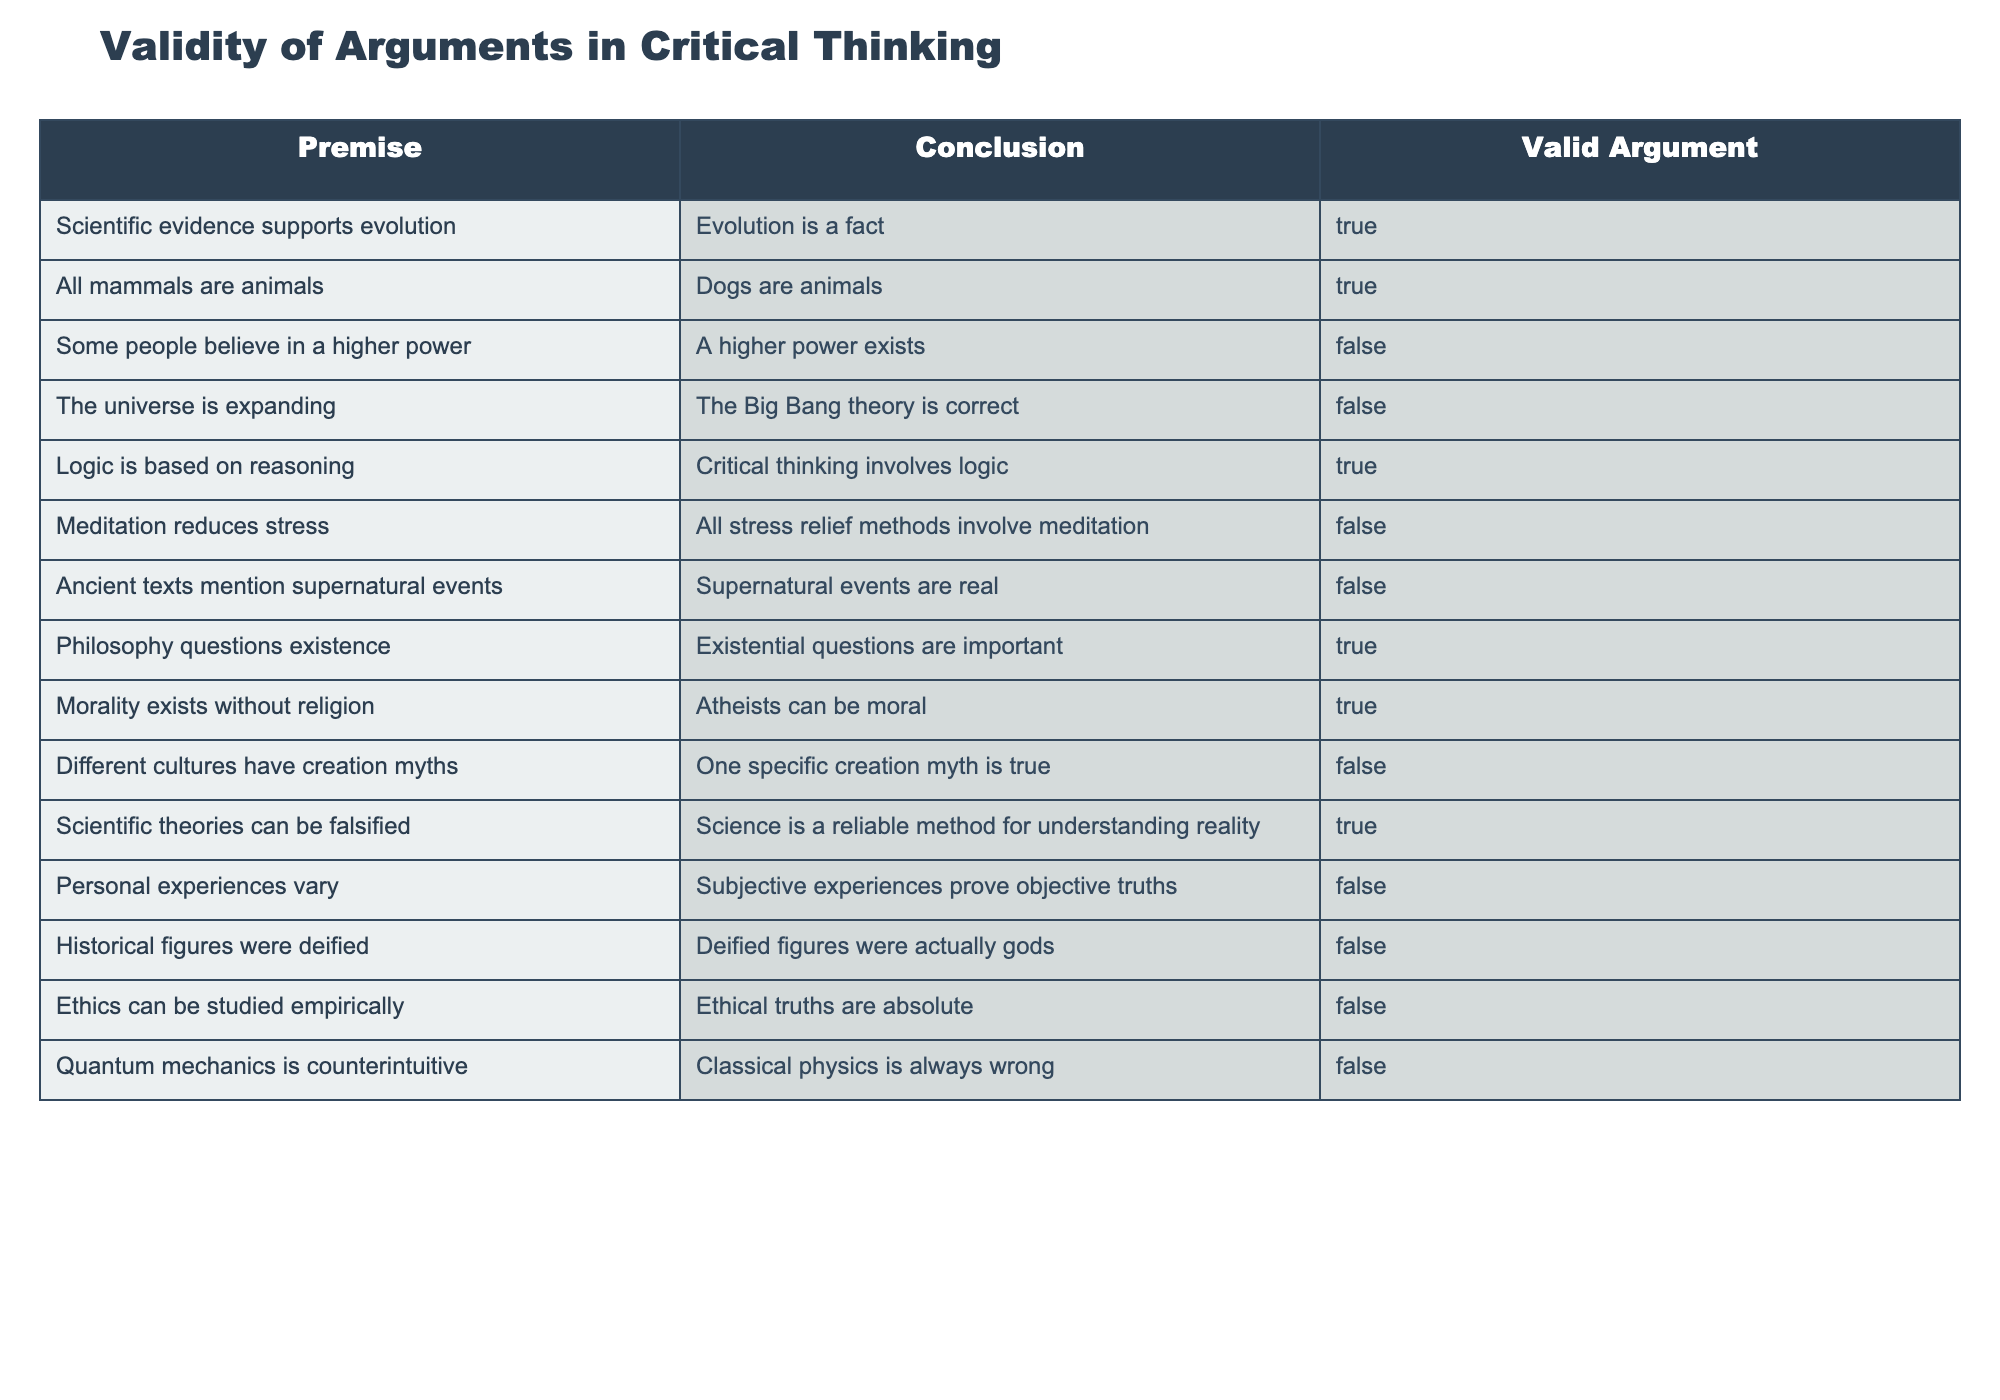What is the conclusion when "scientific evidence supports evolution"? According to the table, when the premise "scientific evidence supports evolution" is true, the conclusion "evolution is a fact" is also marked as true.
Answer: true How many valid arguments are there in total? By counting the rows in the table, there are 8 valid arguments (marked as true).
Answer: 8 Is the statement "Some people believe in a higher power" considered a valid argument leading to the conclusion "A higher power exists"? The table shows that this premise leads to a conclusion that is marked as false, meaning this argument is not valid.
Answer: false What can we infer about the relationship between premise "The universe is expanding" and conclusion "The Big Bang theory is correct"? The table indicates that this premise leads to a false conclusion, showing that the argument is not valid. This suggests that simply knowing one is true does not guarantee the truth of the other.
Answer: false When both "quantum mechanics is counterintuitive" and "classical physics is always wrong" are examined, is there an implied valid argument? The table shows both statements are false. Therefore, the implication of a valid argument does not hold regardless of the premises, demonstrating a lack of direct logical connection established by these arguments.
Answer: false 